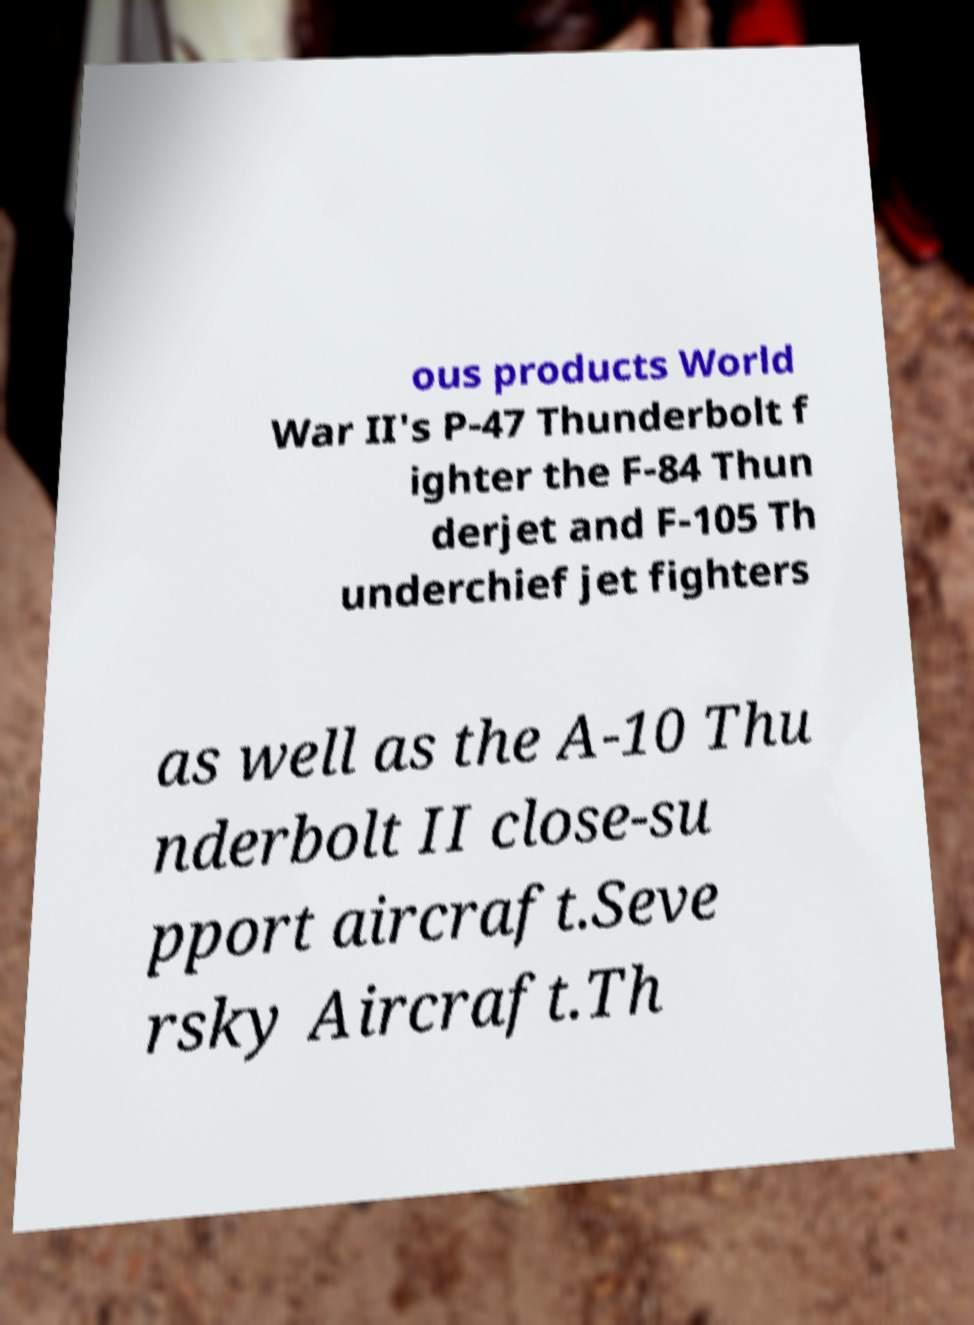What messages or text are displayed in this image? I need them in a readable, typed format. ous products World War II's P-47 Thunderbolt f ighter the F-84 Thun derjet and F-105 Th underchief jet fighters as well as the A-10 Thu nderbolt II close-su pport aircraft.Seve rsky Aircraft.Th 